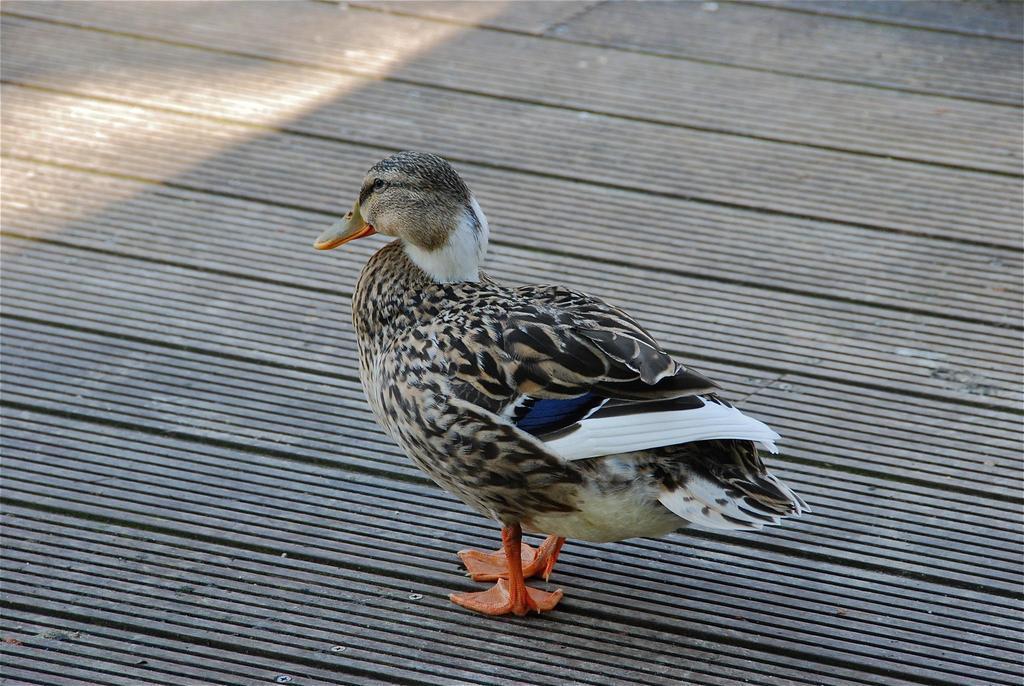Please provide a concise description of this image. In this image we can see a duck on the floor. 